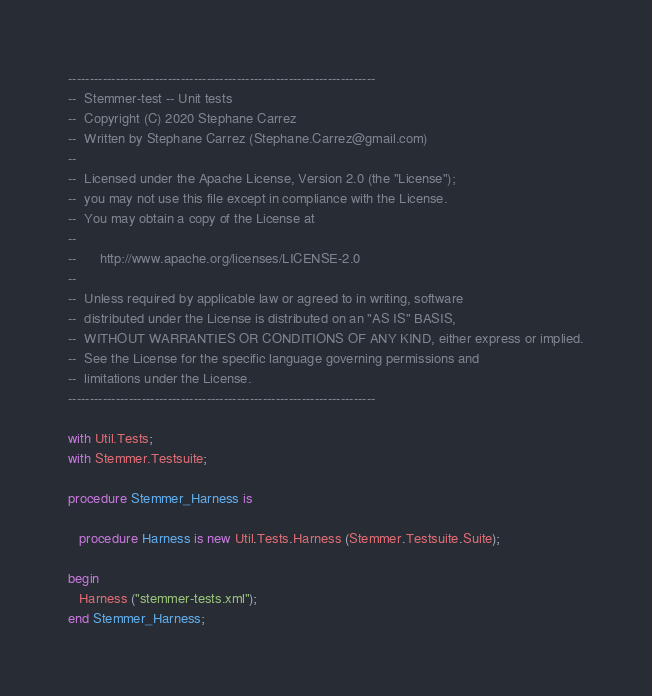Convert code to text. <code><loc_0><loc_0><loc_500><loc_500><_Ada_>-----------------------------------------------------------------------
--  Stemmer-test -- Unit tests
--  Copyright (C) 2020 Stephane Carrez
--  Written by Stephane Carrez (Stephane.Carrez@gmail.com)
--
--  Licensed under the Apache License, Version 2.0 (the "License");
--  you may not use this file except in compliance with the License.
--  You may obtain a copy of the License at
--
--      http://www.apache.org/licenses/LICENSE-2.0
--
--  Unless required by applicable law or agreed to in writing, software
--  distributed under the License is distributed on an "AS IS" BASIS,
--  WITHOUT WARRANTIES OR CONDITIONS OF ANY KIND, either express or implied.
--  See the License for the specific language governing permissions and
--  limitations under the License.
-----------------------------------------------------------------------

with Util.Tests;
with Stemmer.Testsuite;

procedure Stemmer_Harness is

   procedure Harness is new Util.Tests.Harness (Stemmer.Testsuite.Suite);

begin
   Harness ("stemmer-tests.xml");
end Stemmer_Harness;
</code> 